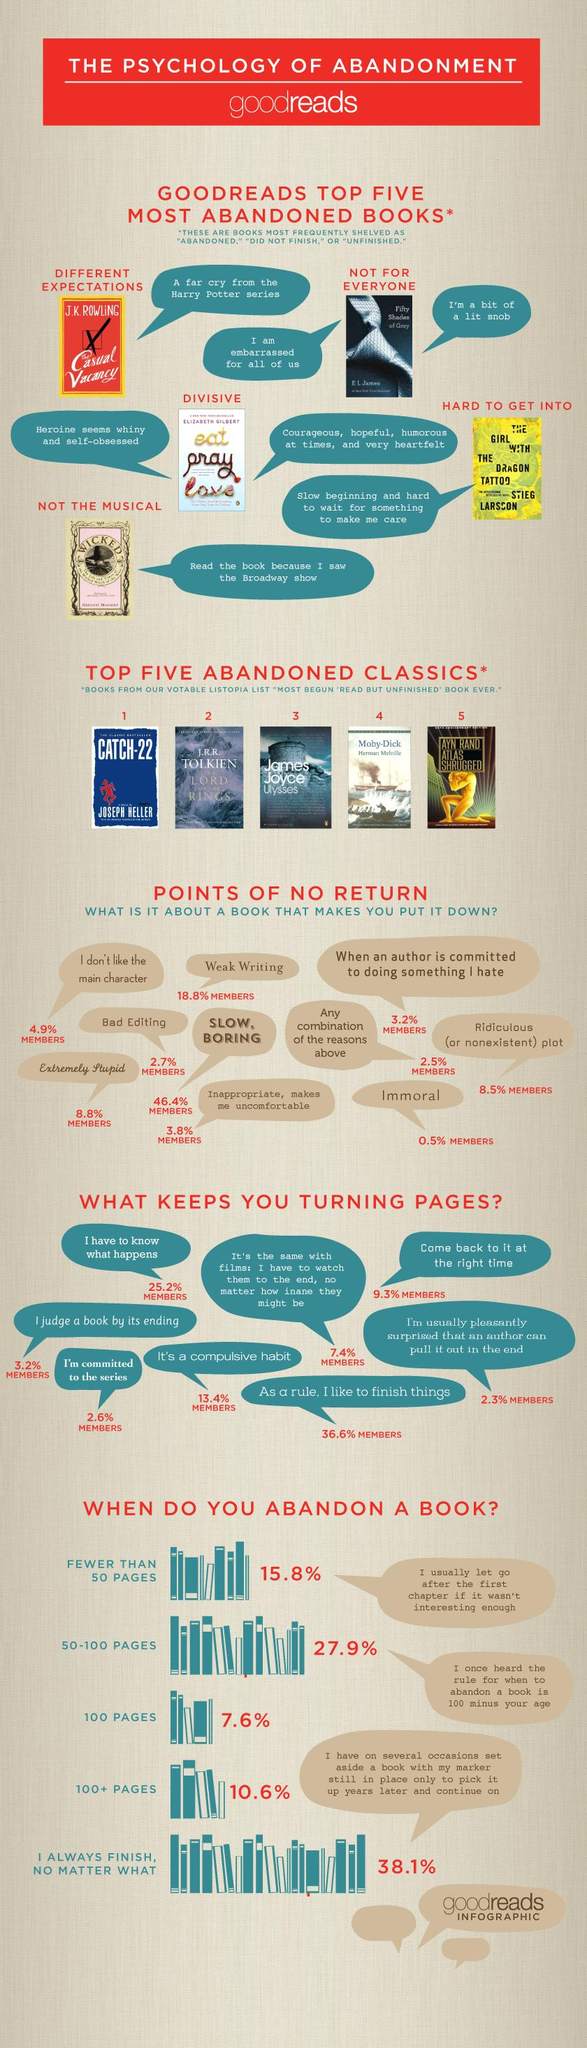Identify some key points in this picture. A recent study found that only 38.1% of people complete a book all the way through. According to the results, 21.5% of members indicated that they refused to finish a book due to poor editing and weak writing. The biggest reason to stop reading a book is when it is slow and boring. The book 'Eat Pray Love' was abandoned by many due to the heroine's perceived whiny and self-obsessed behavior. A staggering 8.5% of members state that a poorly developed or nonexistent plot is the reason they abandon a book. 